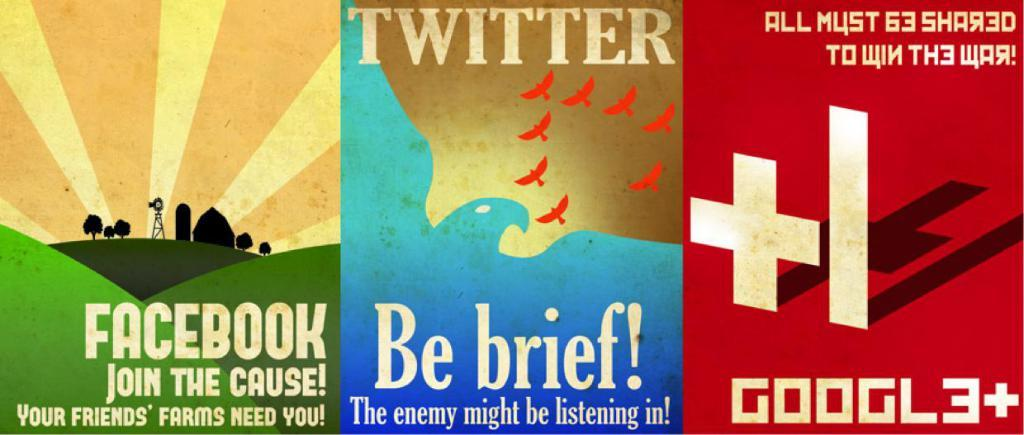<image>
Share a concise interpretation of the image provided. Three images including Facebook on one with another titled Twitter. 